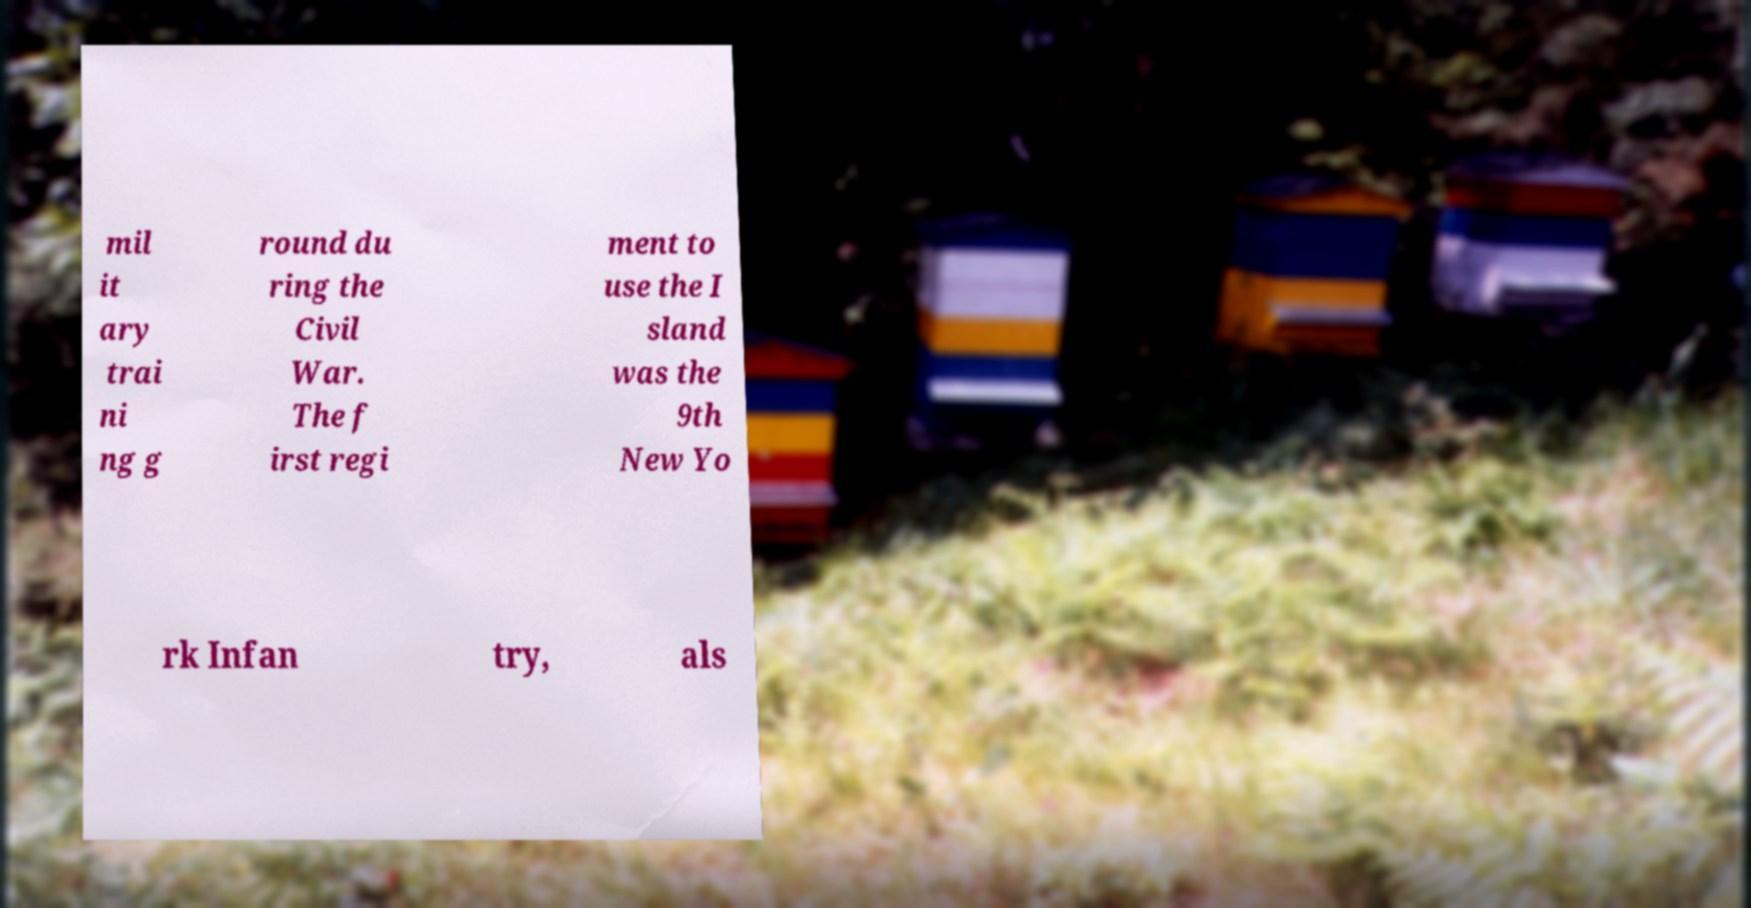Can you describe what's visible in the background of this image? Behind the document, we see a blurry view of what seem to be beehives set against a natural backdrop, illustrating perhaps a peaceful setting that contrasts with the military content mentioned in the text. 